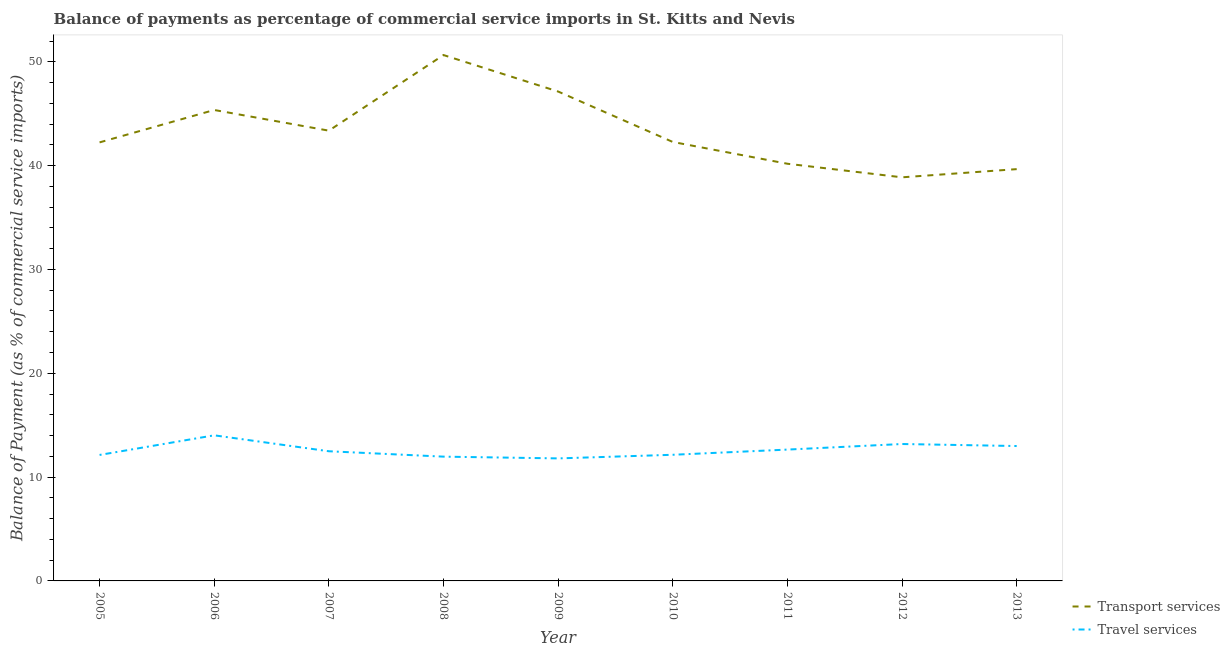How many different coloured lines are there?
Offer a very short reply. 2. Is the number of lines equal to the number of legend labels?
Offer a terse response. Yes. What is the balance of payments of travel services in 2008?
Offer a very short reply. 11.97. Across all years, what is the maximum balance of payments of travel services?
Offer a terse response. 14.03. Across all years, what is the minimum balance of payments of transport services?
Make the answer very short. 38.88. In which year was the balance of payments of transport services maximum?
Offer a very short reply. 2008. What is the total balance of payments of transport services in the graph?
Offer a terse response. 389.78. What is the difference between the balance of payments of transport services in 2008 and that in 2013?
Your response must be concise. 10.99. What is the difference between the balance of payments of transport services in 2013 and the balance of payments of travel services in 2010?
Your answer should be very brief. 27.51. What is the average balance of payments of transport services per year?
Offer a very short reply. 43.31. In the year 2011, what is the difference between the balance of payments of transport services and balance of payments of travel services?
Ensure brevity in your answer.  27.53. In how many years, is the balance of payments of travel services greater than 4 %?
Provide a short and direct response. 9. What is the ratio of the balance of payments of transport services in 2008 to that in 2013?
Keep it short and to the point. 1.28. Is the balance of payments of transport services in 2005 less than that in 2008?
Provide a short and direct response. Yes. What is the difference between the highest and the second highest balance of payments of travel services?
Provide a short and direct response. 0.84. What is the difference between the highest and the lowest balance of payments of travel services?
Your answer should be very brief. 2.22. In how many years, is the balance of payments of transport services greater than the average balance of payments of transport services taken over all years?
Make the answer very short. 4. Is the balance of payments of transport services strictly greater than the balance of payments of travel services over the years?
Make the answer very short. Yes. Is the balance of payments of travel services strictly less than the balance of payments of transport services over the years?
Offer a terse response. Yes. How many lines are there?
Ensure brevity in your answer.  2. How many years are there in the graph?
Provide a short and direct response. 9. Does the graph contain grids?
Your answer should be very brief. No. Where does the legend appear in the graph?
Provide a short and direct response. Bottom right. How many legend labels are there?
Your answer should be compact. 2. What is the title of the graph?
Give a very brief answer. Balance of payments as percentage of commercial service imports in St. Kitts and Nevis. Does "Secondary" appear as one of the legend labels in the graph?
Offer a terse response. No. What is the label or title of the Y-axis?
Your answer should be compact. Balance of Payment (as % of commercial service imports). What is the Balance of Payment (as % of commercial service imports) of Transport services in 2005?
Ensure brevity in your answer.  42.24. What is the Balance of Payment (as % of commercial service imports) of Travel services in 2005?
Give a very brief answer. 12.13. What is the Balance of Payment (as % of commercial service imports) of Transport services in 2006?
Ensure brevity in your answer.  45.36. What is the Balance of Payment (as % of commercial service imports) in Travel services in 2006?
Your answer should be very brief. 14.03. What is the Balance of Payment (as % of commercial service imports) of Transport services in 2007?
Give a very brief answer. 43.37. What is the Balance of Payment (as % of commercial service imports) of Travel services in 2007?
Your response must be concise. 12.49. What is the Balance of Payment (as % of commercial service imports) in Transport services in 2008?
Provide a succinct answer. 50.65. What is the Balance of Payment (as % of commercial service imports) of Travel services in 2008?
Offer a terse response. 11.97. What is the Balance of Payment (as % of commercial service imports) in Transport services in 2009?
Provide a succinct answer. 47.14. What is the Balance of Payment (as % of commercial service imports) of Travel services in 2009?
Make the answer very short. 11.8. What is the Balance of Payment (as % of commercial service imports) of Transport services in 2010?
Give a very brief answer. 42.28. What is the Balance of Payment (as % of commercial service imports) in Travel services in 2010?
Provide a succinct answer. 12.15. What is the Balance of Payment (as % of commercial service imports) of Transport services in 2011?
Offer a terse response. 40.18. What is the Balance of Payment (as % of commercial service imports) in Travel services in 2011?
Ensure brevity in your answer.  12.65. What is the Balance of Payment (as % of commercial service imports) in Transport services in 2012?
Make the answer very short. 38.88. What is the Balance of Payment (as % of commercial service imports) in Travel services in 2012?
Your response must be concise. 13.19. What is the Balance of Payment (as % of commercial service imports) of Transport services in 2013?
Ensure brevity in your answer.  39.66. What is the Balance of Payment (as % of commercial service imports) of Travel services in 2013?
Keep it short and to the point. 12.99. Across all years, what is the maximum Balance of Payment (as % of commercial service imports) in Transport services?
Offer a terse response. 50.65. Across all years, what is the maximum Balance of Payment (as % of commercial service imports) in Travel services?
Your answer should be very brief. 14.03. Across all years, what is the minimum Balance of Payment (as % of commercial service imports) of Transport services?
Provide a succinct answer. 38.88. Across all years, what is the minimum Balance of Payment (as % of commercial service imports) in Travel services?
Provide a succinct answer. 11.8. What is the total Balance of Payment (as % of commercial service imports) in Transport services in the graph?
Provide a succinct answer. 389.78. What is the total Balance of Payment (as % of commercial service imports) in Travel services in the graph?
Give a very brief answer. 113.4. What is the difference between the Balance of Payment (as % of commercial service imports) of Transport services in 2005 and that in 2006?
Make the answer very short. -3.12. What is the difference between the Balance of Payment (as % of commercial service imports) of Travel services in 2005 and that in 2006?
Provide a succinct answer. -1.89. What is the difference between the Balance of Payment (as % of commercial service imports) in Transport services in 2005 and that in 2007?
Your answer should be very brief. -1.13. What is the difference between the Balance of Payment (as % of commercial service imports) in Travel services in 2005 and that in 2007?
Offer a very short reply. -0.36. What is the difference between the Balance of Payment (as % of commercial service imports) of Transport services in 2005 and that in 2008?
Offer a terse response. -8.41. What is the difference between the Balance of Payment (as % of commercial service imports) of Travel services in 2005 and that in 2008?
Your response must be concise. 0.16. What is the difference between the Balance of Payment (as % of commercial service imports) of Transport services in 2005 and that in 2009?
Make the answer very short. -4.9. What is the difference between the Balance of Payment (as % of commercial service imports) of Travel services in 2005 and that in 2009?
Provide a succinct answer. 0.33. What is the difference between the Balance of Payment (as % of commercial service imports) in Transport services in 2005 and that in 2010?
Your answer should be very brief. -0.04. What is the difference between the Balance of Payment (as % of commercial service imports) of Travel services in 2005 and that in 2010?
Your answer should be very brief. -0.02. What is the difference between the Balance of Payment (as % of commercial service imports) of Transport services in 2005 and that in 2011?
Your answer should be very brief. 2.06. What is the difference between the Balance of Payment (as % of commercial service imports) in Travel services in 2005 and that in 2011?
Offer a very short reply. -0.52. What is the difference between the Balance of Payment (as % of commercial service imports) of Transport services in 2005 and that in 2012?
Ensure brevity in your answer.  3.37. What is the difference between the Balance of Payment (as % of commercial service imports) of Travel services in 2005 and that in 2012?
Your answer should be compact. -1.05. What is the difference between the Balance of Payment (as % of commercial service imports) in Transport services in 2005 and that in 2013?
Ensure brevity in your answer.  2.58. What is the difference between the Balance of Payment (as % of commercial service imports) of Travel services in 2005 and that in 2013?
Your answer should be compact. -0.86. What is the difference between the Balance of Payment (as % of commercial service imports) in Transport services in 2006 and that in 2007?
Keep it short and to the point. 1.99. What is the difference between the Balance of Payment (as % of commercial service imports) in Travel services in 2006 and that in 2007?
Offer a very short reply. 1.53. What is the difference between the Balance of Payment (as % of commercial service imports) of Transport services in 2006 and that in 2008?
Your answer should be very brief. -5.29. What is the difference between the Balance of Payment (as % of commercial service imports) of Travel services in 2006 and that in 2008?
Offer a terse response. 2.05. What is the difference between the Balance of Payment (as % of commercial service imports) of Transport services in 2006 and that in 2009?
Your response must be concise. -1.78. What is the difference between the Balance of Payment (as % of commercial service imports) of Travel services in 2006 and that in 2009?
Your response must be concise. 2.22. What is the difference between the Balance of Payment (as % of commercial service imports) of Transport services in 2006 and that in 2010?
Ensure brevity in your answer.  3.08. What is the difference between the Balance of Payment (as % of commercial service imports) in Travel services in 2006 and that in 2010?
Ensure brevity in your answer.  1.87. What is the difference between the Balance of Payment (as % of commercial service imports) in Transport services in 2006 and that in 2011?
Offer a very short reply. 5.18. What is the difference between the Balance of Payment (as % of commercial service imports) in Travel services in 2006 and that in 2011?
Offer a terse response. 1.37. What is the difference between the Balance of Payment (as % of commercial service imports) in Transport services in 2006 and that in 2012?
Offer a terse response. 6.49. What is the difference between the Balance of Payment (as % of commercial service imports) of Travel services in 2006 and that in 2012?
Offer a very short reply. 0.84. What is the difference between the Balance of Payment (as % of commercial service imports) of Transport services in 2006 and that in 2013?
Your answer should be very brief. 5.7. What is the difference between the Balance of Payment (as % of commercial service imports) in Travel services in 2006 and that in 2013?
Provide a short and direct response. 1.03. What is the difference between the Balance of Payment (as % of commercial service imports) of Transport services in 2007 and that in 2008?
Provide a succinct answer. -7.28. What is the difference between the Balance of Payment (as % of commercial service imports) in Travel services in 2007 and that in 2008?
Give a very brief answer. 0.52. What is the difference between the Balance of Payment (as % of commercial service imports) in Transport services in 2007 and that in 2009?
Offer a terse response. -3.77. What is the difference between the Balance of Payment (as % of commercial service imports) of Travel services in 2007 and that in 2009?
Provide a succinct answer. 0.69. What is the difference between the Balance of Payment (as % of commercial service imports) of Transport services in 2007 and that in 2010?
Your answer should be very brief. 1.09. What is the difference between the Balance of Payment (as % of commercial service imports) in Travel services in 2007 and that in 2010?
Your answer should be compact. 0.34. What is the difference between the Balance of Payment (as % of commercial service imports) of Transport services in 2007 and that in 2011?
Your answer should be very brief. 3.19. What is the difference between the Balance of Payment (as % of commercial service imports) in Travel services in 2007 and that in 2011?
Offer a very short reply. -0.16. What is the difference between the Balance of Payment (as % of commercial service imports) of Transport services in 2007 and that in 2012?
Offer a very short reply. 4.49. What is the difference between the Balance of Payment (as % of commercial service imports) of Travel services in 2007 and that in 2012?
Provide a succinct answer. -0.7. What is the difference between the Balance of Payment (as % of commercial service imports) of Transport services in 2007 and that in 2013?
Offer a very short reply. 3.71. What is the difference between the Balance of Payment (as % of commercial service imports) in Travel services in 2007 and that in 2013?
Ensure brevity in your answer.  -0.5. What is the difference between the Balance of Payment (as % of commercial service imports) of Transport services in 2008 and that in 2009?
Provide a short and direct response. 3.51. What is the difference between the Balance of Payment (as % of commercial service imports) of Travel services in 2008 and that in 2009?
Offer a terse response. 0.17. What is the difference between the Balance of Payment (as % of commercial service imports) of Transport services in 2008 and that in 2010?
Offer a terse response. 8.37. What is the difference between the Balance of Payment (as % of commercial service imports) of Travel services in 2008 and that in 2010?
Offer a terse response. -0.18. What is the difference between the Balance of Payment (as % of commercial service imports) in Transport services in 2008 and that in 2011?
Your response must be concise. 10.47. What is the difference between the Balance of Payment (as % of commercial service imports) of Travel services in 2008 and that in 2011?
Ensure brevity in your answer.  -0.68. What is the difference between the Balance of Payment (as % of commercial service imports) of Transport services in 2008 and that in 2012?
Keep it short and to the point. 11.78. What is the difference between the Balance of Payment (as % of commercial service imports) in Travel services in 2008 and that in 2012?
Keep it short and to the point. -1.22. What is the difference between the Balance of Payment (as % of commercial service imports) in Transport services in 2008 and that in 2013?
Make the answer very short. 10.99. What is the difference between the Balance of Payment (as % of commercial service imports) in Travel services in 2008 and that in 2013?
Make the answer very short. -1.02. What is the difference between the Balance of Payment (as % of commercial service imports) of Transport services in 2009 and that in 2010?
Give a very brief answer. 4.86. What is the difference between the Balance of Payment (as % of commercial service imports) in Travel services in 2009 and that in 2010?
Give a very brief answer. -0.35. What is the difference between the Balance of Payment (as % of commercial service imports) of Transport services in 2009 and that in 2011?
Offer a very short reply. 6.96. What is the difference between the Balance of Payment (as % of commercial service imports) in Travel services in 2009 and that in 2011?
Provide a succinct answer. -0.85. What is the difference between the Balance of Payment (as % of commercial service imports) of Transport services in 2009 and that in 2012?
Keep it short and to the point. 8.26. What is the difference between the Balance of Payment (as % of commercial service imports) in Travel services in 2009 and that in 2012?
Give a very brief answer. -1.39. What is the difference between the Balance of Payment (as % of commercial service imports) in Transport services in 2009 and that in 2013?
Provide a short and direct response. 7.48. What is the difference between the Balance of Payment (as % of commercial service imports) of Travel services in 2009 and that in 2013?
Provide a short and direct response. -1.19. What is the difference between the Balance of Payment (as % of commercial service imports) of Transport services in 2010 and that in 2011?
Keep it short and to the point. 2.1. What is the difference between the Balance of Payment (as % of commercial service imports) of Travel services in 2010 and that in 2011?
Provide a short and direct response. -0.5. What is the difference between the Balance of Payment (as % of commercial service imports) of Transport services in 2010 and that in 2012?
Your answer should be compact. 3.41. What is the difference between the Balance of Payment (as % of commercial service imports) in Travel services in 2010 and that in 2012?
Provide a short and direct response. -1.04. What is the difference between the Balance of Payment (as % of commercial service imports) of Transport services in 2010 and that in 2013?
Your response must be concise. 2.62. What is the difference between the Balance of Payment (as % of commercial service imports) in Travel services in 2010 and that in 2013?
Your answer should be very brief. -0.84. What is the difference between the Balance of Payment (as % of commercial service imports) in Transport services in 2011 and that in 2012?
Provide a short and direct response. 1.31. What is the difference between the Balance of Payment (as % of commercial service imports) of Travel services in 2011 and that in 2012?
Ensure brevity in your answer.  -0.54. What is the difference between the Balance of Payment (as % of commercial service imports) of Transport services in 2011 and that in 2013?
Provide a short and direct response. 0.52. What is the difference between the Balance of Payment (as % of commercial service imports) of Travel services in 2011 and that in 2013?
Ensure brevity in your answer.  -0.34. What is the difference between the Balance of Payment (as % of commercial service imports) of Transport services in 2012 and that in 2013?
Make the answer very short. -0.79. What is the difference between the Balance of Payment (as % of commercial service imports) of Travel services in 2012 and that in 2013?
Offer a terse response. 0.2. What is the difference between the Balance of Payment (as % of commercial service imports) of Transport services in 2005 and the Balance of Payment (as % of commercial service imports) of Travel services in 2006?
Offer a very short reply. 28.22. What is the difference between the Balance of Payment (as % of commercial service imports) in Transport services in 2005 and the Balance of Payment (as % of commercial service imports) in Travel services in 2007?
Give a very brief answer. 29.75. What is the difference between the Balance of Payment (as % of commercial service imports) in Transport services in 2005 and the Balance of Payment (as % of commercial service imports) in Travel services in 2008?
Keep it short and to the point. 30.27. What is the difference between the Balance of Payment (as % of commercial service imports) of Transport services in 2005 and the Balance of Payment (as % of commercial service imports) of Travel services in 2009?
Provide a succinct answer. 30.44. What is the difference between the Balance of Payment (as % of commercial service imports) of Transport services in 2005 and the Balance of Payment (as % of commercial service imports) of Travel services in 2010?
Your answer should be compact. 30.09. What is the difference between the Balance of Payment (as % of commercial service imports) of Transport services in 2005 and the Balance of Payment (as % of commercial service imports) of Travel services in 2011?
Ensure brevity in your answer.  29.59. What is the difference between the Balance of Payment (as % of commercial service imports) in Transport services in 2005 and the Balance of Payment (as % of commercial service imports) in Travel services in 2012?
Your response must be concise. 29.05. What is the difference between the Balance of Payment (as % of commercial service imports) in Transport services in 2005 and the Balance of Payment (as % of commercial service imports) in Travel services in 2013?
Provide a succinct answer. 29.25. What is the difference between the Balance of Payment (as % of commercial service imports) in Transport services in 2006 and the Balance of Payment (as % of commercial service imports) in Travel services in 2007?
Your answer should be compact. 32.87. What is the difference between the Balance of Payment (as % of commercial service imports) in Transport services in 2006 and the Balance of Payment (as % of commercial service imports) in Travel services in 2008?
Ensure brevity in your answer.  33.39. What is the difference between the Balance of Payment (as % of commercial service imports) in Transport services in 2006 and the Balance of Payment (as % of commercial service imports) in Travel services in 2009?
Your response must be concise. 33.56. What is the difference between the Balance of Payment (as % of commercial service imports) of Transport services in 2006 and the Balance of Payment (as % of commercial service imports) of Travel services in 2010?
Your answer should be compact. 33.21. What is the difference between the Balance of Payment (as % of commercial service imports) of Transport services in 2006 and the Balance of Payment (as % of commercial service imports) of Travel services in 2011?
Ensure brevity in your answer.  32.71. What is the difference between the Balance of Payment (as % of commercial service imports) of Transport services in 2006 and the Balance of Payment (as % of commercial service imports) of Travel services in 2012?
Your answer should be compact. 32.17. What is the difference between the Balance of Payment (as % of commercial service imports) of Transport services in 2006 and the Balance of Payment (as % of commercial service imports) of Travel services in 2013?
Offer a very short reply. 32.37. What is the difference between the Balance of Payment (as % of commercial service imports) in Transport services in 2007 and the Balance of Payment (as % of commercial service imports) in Travel services in 2008?
Ensure brevity in your answer.  31.4. What is the difference between the Balance of Payment (as % of commercial service imports) in Transport services in 2007 and the Balance of Payment (as % of commercial service imports) in Travel services in 2009?
Provide a short and direct response. 31.57. What is the difference between the Balance of Payment (as % of commercial service imports) in Transport services in 2007 and the Balance of Payment (as % of commercial service imports) in Travel services in 2010?
Your answer should be very brief. 31.22. What is the difference between the Balance of Payment (as % of commercial service imports) in Transport services in 2007 and the Balance of Payment (as % of commercial service imports) in Travel services in 2011?
Keep it short and to the point. 30.72. What is the difference between the Balance of Payment (as % of commercial service imports) in Transport services in 2007 and the Balance of Payment (as % of commercial service imports) in Travel services in 2012?
Give a very brief answer. 30.18. What is the difference between the Balance of Payment (as % of commercial service imports) of Transport services in 2007 and the Balance of Payment (as % of commercial service imports) of Travel services in 2013?
Offer a terse response. 30.38. What is the difference between the Balance of Payment (as % of commercial service imports) of Transport services in 2008 and the Balance of Payment (as % of commercial service imports) of Travel services in 2009?
Provide a succinct answer. 38.85. What is the difference between the Balance of Payment (as % of commercial service imports) of Transport services in 2008 and the Balance of Payment (as % of commercial service imports) of Travel services in 2010?
Give a very brief answer. 38.5. What is the difference between the Balance of Payment (as % of commercial service imports) in Transport services in 2008 and the Balance of Payment (as % of commercial service imports) in Travel services in 2011?
Your answer should be compact. 38. What is the difference between the Balance of Payment (as % of commercial service imports) of Transport services in 2008 and the Balance of Payment (as % of commercial service imports) of Travel services in 2012?
Provide a succinct answer. 37.47. What is the difference between the Balance of Payment (as % of commercial service imports) in Transport services in 2008 and the Balance of Payment (as % of commercial service imports) in Travel services in 2013?
Keep it short and to the point. 37.66. What is the difference between the Balance of Payment (as % of commercial service imports) in Transport services in 2009 and the Balance of Payment (as % of commercial service imports) in Travel services in 2010?
Offer a terse response. 34.99. What is the difference between the Balance of Payment (as % of commercial service imports) in Transport services in 2009 and the Balance of Payment (as % of commercial service imports) in Travel services in 2011?
Your answer should be very brief. 34.49. What is the difference between the Balance of Payment (as % of commercial service imports) in Transport services in 2009 and the Balance of Payment (as % of commercial service imports) in Travel services in 2012?
Your answer should be very brief. 33.95. What is the difference between the Balance of Payment (as % of commercial service imports) of Transport services in 2009 and the Balance of Payment (as % of commercial service imports) of Travel services in 2013?
Keep it short and to the point. 34.15. What is the difference between the Balance of Payment (as % of commercial service imports) of Transport services in 2010 and the Balance of Payment (as % of commercial service imports) of Travel services in 2011?
Your answer should be compact. 29.63. What is the difference between the Balance of Payment (as % of commercial service imports) of Transport services in 2010 and the Balance of Payment (as % of commercial service imports) of Travel services in 2012?
Your answer should be very brief. 29.09. What is the difference between the Balance of Payment (as % of commercial service imports) of Transport services in 2010 and the Balance of Payment (as % of commercial service imports) of Travel services in 2013?
Provide a short and direct response. 29.29. What is the difference between the Balance of Payment (as % of commercial service imports) in Transport services in 2011 and the Balance of Payment (as % of commercial service imports) in Travel services in 2012?
Offer a terse response. 27. What is the difference between the Balance of Payment (as % of commercial service imports) in Transport services in 2011 and the Balance of Payment (as % of commercial service imports) in Travel services in 2013?
Give a very brief answer. 27.19. What is the difference between the Balance of Payment (as % of commercial service imports) in Transport services in 2012 and the Balance of Payment (as % of commercial service imports) in Travel services in 2013?
Provide a succinct answer. 25.88. What is the average Balance of Payment (as % of commercial service imports) of Transport services per year?
Offer a very short reply. 43.31. What is the average Balance of Payment (as % of commercial service imports) in Travel services per year?
Your answer should be very brief. 12.6. In the year 2005, what is the difference between the Balance of Payment (as % of commercial service imports) of Transport services and Balance of Payment (as % of commercial service imports) of Travel services?
Make the answer very short. 30.11. In the year 2006, what is the difference between the Balance of Payment (as % of commercial service imports) of Transport services and Balance of Payment (as % of commercial service imports) of Travel services?
Your answer should be very brief. 31.34. In the year 2007, what is the difference between the Balance of Payment (as % of commercial service imports) in Transport services and Balance of Payment (as % of commercial service imports) in Travel services?
Keep it short and to the point. 30.88. In the year 2008, what is the difference between the Balance of Payment (as % of commercial service imports) in Transport services and Balance of Payment (as % of commercial service imports) in Travel services?
Make the answer very short. 38.68. In the year 2009, what is the difference between the Balance of Payment (as % of commercial service imports) of Transport services and Balance of Payment (as % of commercial service imports) of Travel services?
Your answer should be very brief. 35.34. In the year 2010, what is the difference between the Balance of Payment (as % of commercial service imports) in Transport services and Balance of Payment (as % of commercial service imports) in Travel services?
Your answer should be compact. 30.13. In the year 2011, what is the difference between the Balance of Payment (as % of commercial service imports) of Transport services and Balance of Payment (as % of commercial service imports) of Travel services?
Provide a short and direct response. 27.53. In the year 2012, what is the difference between the Balance of Payment (as % of commercial service imports) in Transport services and Balance of Payment (as % of commercial service imports) in Travel services?
Provide a short and direct response. 25.69. In the year 2013, what is the difference between the Balance of Payment (as % of commercial service imports) of Transport services and Balance of Payment (as % of commercial service imports) of Travel services?
Your response must be concise. 26.67. What is the ratio of the Balance of Payment (as % of commercial service imports) of Transport services in 2005 to that in 2006?
Provide a short and direct response. 0.93. What is the ratio of the Balance of Payment (as % of commercial service imports) in Travel services in 2005 to that in 2006?
Offer a very short reply. 0.87. What is the ratio of the Balance of Payment (as % of commercial service imports) of Transport services in 2005 to that in 2007?
Ensure brevity in your answer.  0.97. What is the ratio of the Balance of Payment (as % of commercial service imports) of Travel services in 2005 to that in 2007?
Ensure brevity in your answer.  0.97. What is the ratio of the Balance of Payment (as % of commercial service imports) in Transport services in 2005 to that in 2008?
Keep it short and to the point. 0.83. What is the ratio of the Balance of Payment (as % of commercial service imports) in Travel services in 2005 to that in 2008?
Your response must be concise. 1.01. What is the ratio of the Balance of Payment (as % of commercial service imports) of Transport services in 2005 to that in 2009?
Keep it short and to the point. 0.9. What is the ratio of the Balance of Payment (as % of commercial service imports) of Travel services in 2005 to that in 2009?
Offer a terse response. 1.03. What is the ratio of the Balance of Payment (as % of commercial service imports) in Travel services in 2005 to that in 2010?
Make the answer very short. 1. What is the ratio of the Balance of Payment (as % of commercial service imports) of Transport services in 2005 to that in 2011?
Offer a terse response. 1.05. What is the ratio of the Balance of Payment (as % of commercial service imports) of Travel services in 2005 to that in 2011?
Keep it short and to the point. 0.96. What is the ratio of the Balance of Payment (as % of commercial service imports) in Transport services in 2005 to that in 2012?
Provide a short and direct response. 1.09. What is the ratio of the Balance of Payment (as % of commercial service imports) of Travel services in 2005 to that in 2012?
Make the answer very short. 0.92. What is the ratio of the Balance of Payment (as % of commercial service imports) in Transport services in 2005 to that in 2013?
Give a very brief answer. 1.06. What is the ratio of the Balance of Payment (as % of commercial service imports) in Travel services in 2005 to that in 2013?
Provide a short and direct response. 0.93. What is the ratio of the Balance of Payment (as % of commercial service imports) of Transport services in 2006 to that in 2007?
Ensure brevity in your answer.  1.05. What is the ratio of the Balance of Payment (as % of commercial service imports) in Travel services in 2006 to that in 2007?
Keep it short and to the point. 1.12. What is the ratio of the Balance of Payment (as % of commercial service imports) in Transport services in 2006 to that in 2008?
Keep it short and to the point. 0.9. What is the ratio of the Balance of Payment (as % of commercial service imports) of Travel services in 2006 to that in 2008?
Your answer should be compact. 1.17. What is the ratio of the Balance of Payment (as % of commercial service imports) of Transport services in 2006 to that in 2009?
Provide a short and direct response. 0.96. What is the ratio of the Balance of Payment (as % of commercial service imports) of Travel services in 2006 to that in 2009?
Ensure brevity in your answer.  1.19. What is the ratio of the Balance of Payment (as % of commercial service imports) of Transport services in 2006 to that in 2010?
Your answer should be very brief. 1.07. What is the ratio of the Balance of Payment (as % of commercial service imports) in Travel services in 2006 to that in 2010?
Make the answer very short. 1.15. What is the ratio of the Balance of Payment (as % of commercial service imports) in Transport services in 2006 to that in 2011?
Offer a terse response. 1.13. What is the ratio of the Balance of Payment (as % of commercial service imports) of Travel services in 2006 to that in 2011?
Keep it short and to the point. 1.11. What is the ratio of the Balance of Payment (as % of commercial service imports) in Transport services in 2006 to that in 2012?
Your answer should be very brief. 1.17. What is the ratio of the Balance of Payment (as % of commercial service imports) of Travel services in 2006 to that in 2012?
Your answer should be very brief. 1.06. What is the ratio of the Balance of Payment (as % of commercial service imports) in Transport services in 2006 to that in 2013?
Your answer should be compact. 1.14. What is the ratio of the Balance of Payment (as % of commercial service imports) of Travel services in 2006 to that in 2013?
Make the answer very short. 1.08. What is the ratio of the Balance of Payment (as % of commercial service imports) in Transport services in 2007 to that in 2008?
Your answer should be very brief. 0.86. What is the ratio of the Balance of Payment (as % of commercial service imports) in Travel services in 2007 to that in 2008?
Your response must be concise. 1.04. What is the ratio of the Balance of Payment (as % of commercial service imports) in Travel services in 2007 to that in 2009?
Provide a short and direct response. 1.06. What is the ratio of the Balance of Payment (as % of commercial service imports) of Transport services in 2007 to that in 2010?
Your answer should be very brief. 1.03. What is the ratio of the Balance of Payment (as % of commercial service imports) of Travel services in 2007 to that in 2010?
Provide a succinct answer. 1.03. What is the ratio of the Balance of Payment (as % of commercial service imports) of Transport services in 2007 to that in 2011?
Offer a very short reply. 1.08. What is the ratio of the Balance of Payment (as % of commercial service imports) of Travel services in 2007 to that in 2011?
Provide a short and direct response. 0.99. What is the ratio of the Balance of Payment (as % of commercial service imports) of Transport services in 2007 to that in 2012?
Your answer should be very brief. 1.12. What is the ratio of the Balance of Payment (as % of commercial service imports) of Travel services in 2007 to that in 2012?
Your answer should be very brief. 0.95. What is the ratio of the Balance of Payment (as % of commercial service imports) of Transport services in 2007 to that in 2013?
Offer a very short reply. 1.09. What is the ratio of the Balance of Payment (as % of commercial service imports) in Travel services in 2007 to that in 2013?
Provide a succinct answer. 0.96. What is the ratio of the Balance of Payment (as % of commercial service imports) of Transport services in 2008 to that in 2009?
Offer a terse response. 1.07. What is the ratio of the Balance of Payment (as % of commercial service imports) in Travel services in 2008 to that in 2009?
Provide a short and direct response. 1.01. What is the ratio of the Balance of Payment (as % of commercial service imports) of Transport services in 2008 to that in 2010?
Provide a succinct answer. 1.2. What is the ratio of the Balance of Payment (as % of commercial service imports) of Travel services in 2008 to that in 2010?
Your answer should be very brief. 0.99. What is the ratio of the Balance of Payment (as % of commercial service imports) of Transport services in 2008 to that in 2011?
Your response must be concise. 1.26. What is the ratio of the Balance of Payment (as % of commercial service imports) in Travel services in 2008 to that in 2011?
Offer a very short reply. 0.95. What is the ratio of the Balance of Payment (as % of commercial service imports) of Transport services in 2008 to that in 2012?
Provide a succinct answer. 1.3. What is the ratio of the Balance of Payment (as % of commercial service imports) of Travel services in 2008 to that in 2012?
Your response must be concise. 0.91. What is the ratio of the Balance of Payment (as % of commercial service imports) of Transport services in 2008 to that in 2013?
Keep it short and to the point. 1.28. What is the ratio of the Balance of Payment (as % of commercial service imports) of Travel services in 2008 to that in 2013?
Make the answer very short. 0.92. What is the ratio of the Balance of Payment (as % of commercial service imports) of Transport services in 2009 to that in 2010?
Your response must be concise. 1.11. What is the ratio of the Balance of Payment (as % of commercial service imports) of Travel services in 2009 to that in 2010?
Offer a terse response. 0.97. What is the ratio of the Balance of Payment (as % of commercial service imports) in Transport services in 2009 to that in 2011?
Make the answer very short. 1.17. What is the ratio of the Balance of Payment (as % of commercial service imports) of Travel services in 2009 to that in 2011?
Provide a short and direct response. 0.93. What is the ratio of the Balance of Payment (as % of commercial service imports) of Transport services in 2009 to that in 2012?
Your answer should be very brief. 1.21. What is the ratio of the Balance of Payment (as % of commercial service imports) of Travel services in 2009 to that in 2012?
Provide a short and direct response. 0.89. What is the ratio of the Balance of Payment (as % of commercial service imports) in Transport services in 2009 to that in 2013?
Make the answer very short. 1.19. What is the ratio of the Balance of Payment (as % of commercial service imports) in Travel services in 2009 to that in 2013?
Ensure brevity in your answer.  0.91. What is the ratio of the Balance of Payment (as % of commercial service imports) in Transport services in 2010 to that in 2011?
Provide a short and direct response. 1.05. What is the ratio of the Balance of Payment (as % of commercial service imports) in Travel services in 2010 to that in 2011?
Give a very brief answer. 0.96. What is the ratio of the Balance of Payment (as % of commercial service imports) in Transport services in 2010 to that in 2012?
Give a very brief answer. 1.09. What is the ratio of the Balance of Payment (as % of commercial service imports) in Travel services in 2010 to that in 2012?
Provide a short and direct response. 0.92. What is the ratio of the Balance of Payment (as % of commercial service imports) of Transport services in 2010 to that in 2013?
Give a very brief answer. 1.07. What is the ratio of the Balance of Payment (as % of commercial service imports) in Travel services in 2010 to that in 2013?
Make the answer very short. 0.94. What is the ratio of the Balance of Payment (as % of commercial service imports) of Transport services in 2011 to that in 2012?
Keep it short and to the point. 1.03. What is the ratio of the Balance of Payment (as % of commercial service imports) in Travel services in 2011 to that in 2012?
Offer a very short reply. 0.96. What is the ratio of the Balance of Payment (as % of commercial service imports) in Transport services in 2011 to that in 2013?
Your answer should be compact. 1.01. What is the ratio of the Balance of Payment (as % of commercial service imports) of Travel services in 2011 to that in 2013?
Your answer should be compact. 0.97. What is the ratio of the Balance of Payment (as % of commercial service imports) in Transport services in 2012 to that in 2013?
Make the answer very short. 0.98. What is the ratio of the Balance of Payment (as % of commercial service imports) of Travel services in 2012 to that in 2013?
Offer a very short reply. 1.02. What is the difference between the highest and the second highest Balance of Payment (as % of commercial service imports) of Transport services?
Make the answer very short. 3.51. What is the difference between the highest and the second highest Balance of Payment (as % of commercial service imports) of Travel services?
Give a very brief answer. 0.84. What is the difference between the highest and the lowest Balance of Payment (as % of commercial service imports) of Transport services?
Keep it short and to the point. 11.78. What is the difference between the highest and the lowest Balance of Payment (as % of commercial service imports) of Travel services?
Provide a short and direct response. 2.22. 